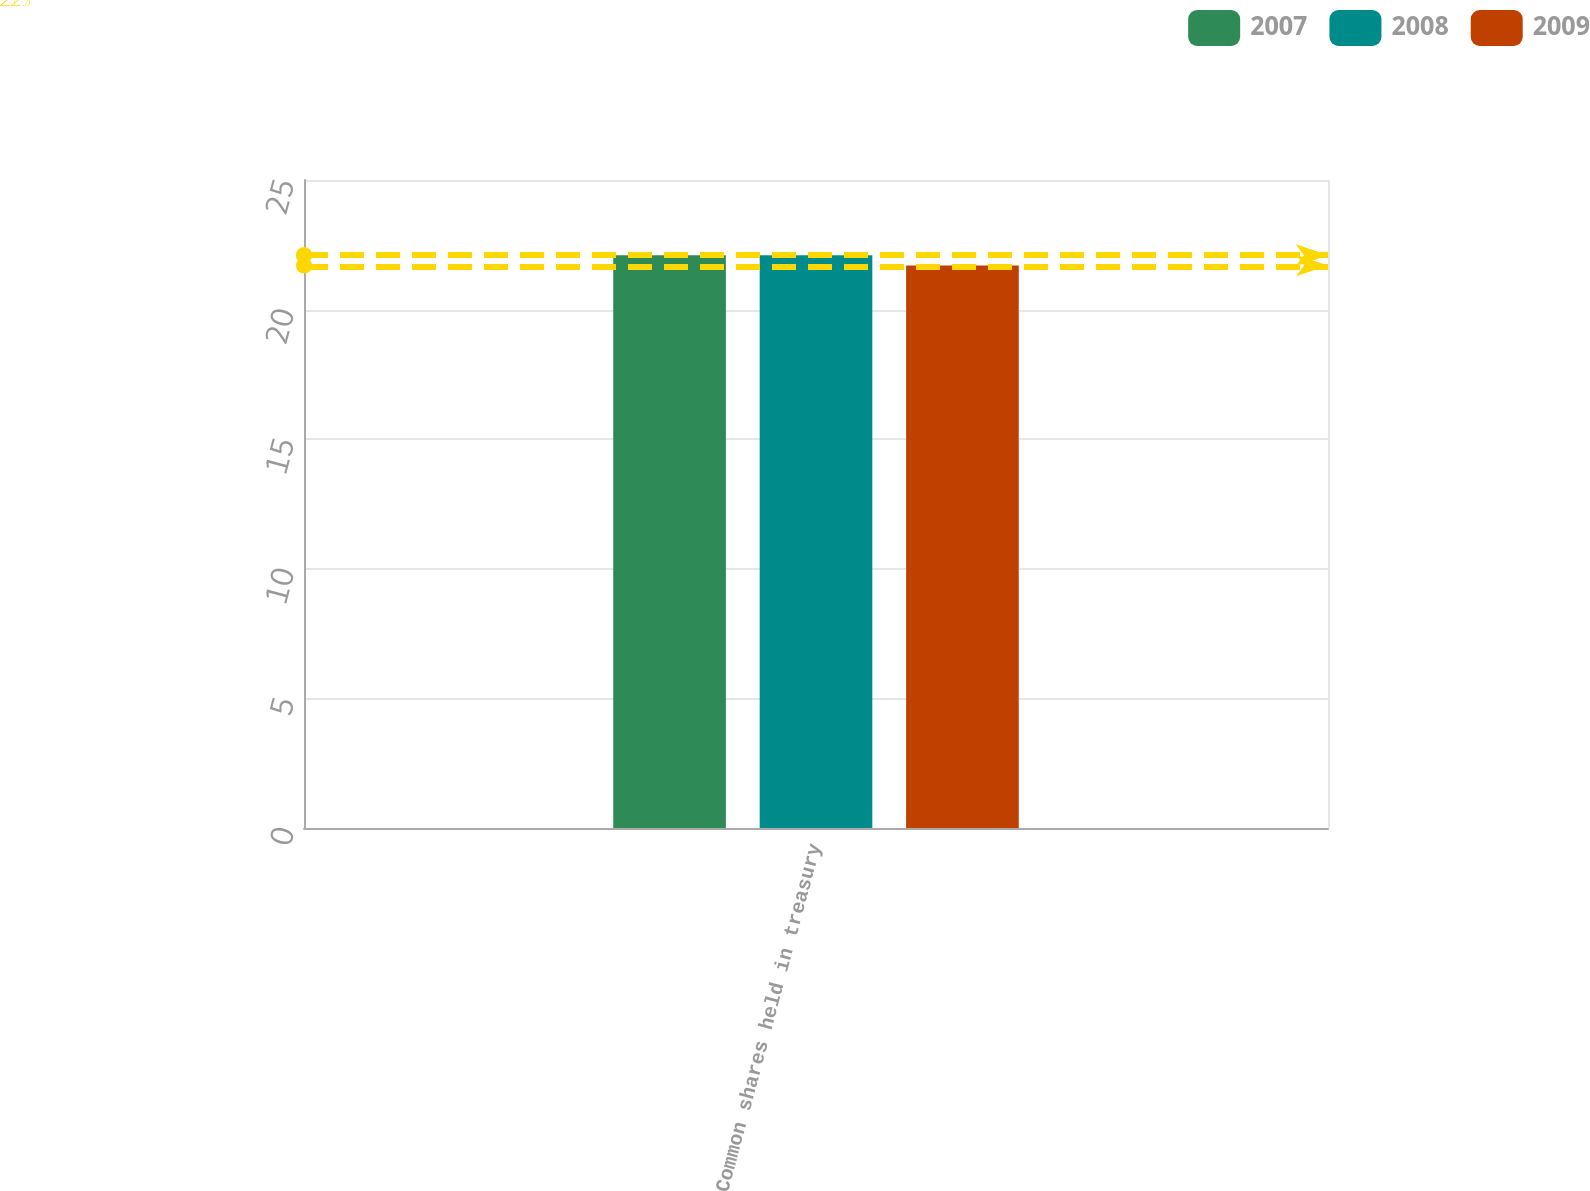<chart> <loc_0><loc_0><loc_500><loc_500><stacked_bar_chart><ecel><fcel>Common shares held in treasury<nl><fcel>2007<fcel>22.1<nl><fcel>2008<fcel>22.1<nl><fcel>2009<fcel>21.7<nl></chart> 